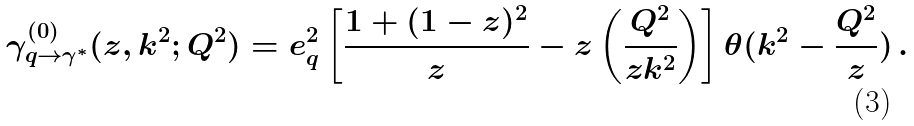Convert formula to latex. <formula><loc_0><loc_0><loc_500><loc_500>\gamma _ { q \rightarrow \gamma ^ { * } } ^ { ( 0 ) } ( z , k ^ { 2 } ; Q ^ { 2 } ) = e _ { q } ^ { 2 } \left [ \frac { 1 + ( 1 - z ) ^ { 2 } } { z } - z \left ( \frac { Q ^ { 2 } } { z k ^ { 2 } } \right ) \right ] \theta ( k ^ { 2 } - \frac { Q ^ { 2 } } { z } ) \, .</formula> 